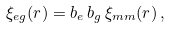Convert formula to latex. <formula><loc_0><loc_0><loc_500><loc_500>\xi _ { e g } ( r ) = b _ { e } \, b _ { g } \, \xi _ { m m } ( r ) \, ,</formula> 